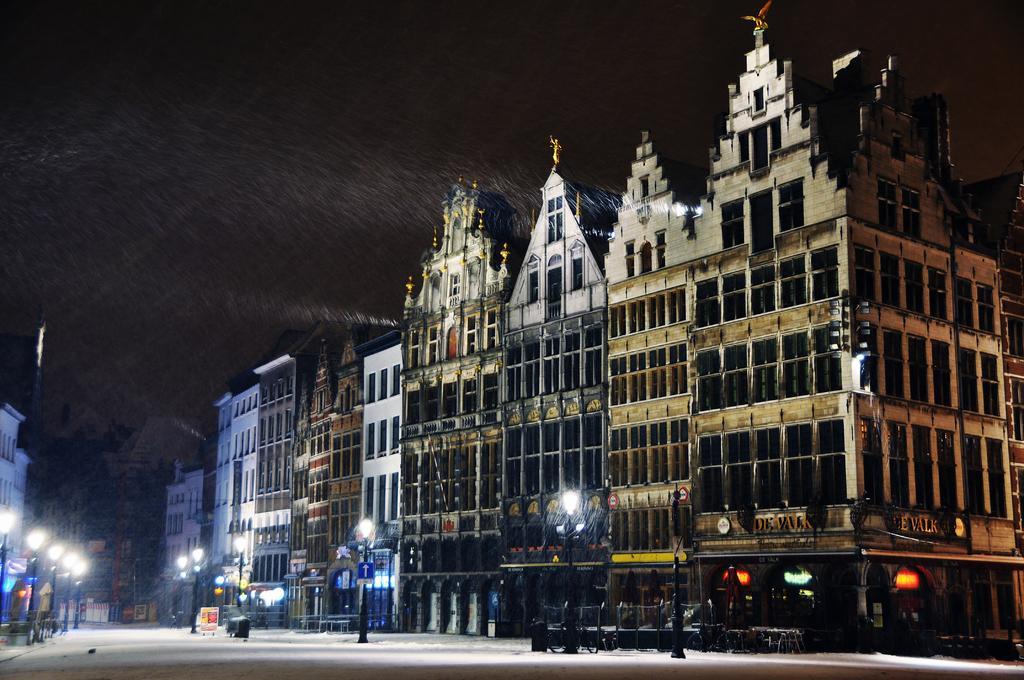How would you summarize this image in a sentence or two? In this image, I can see the buildings with the windows. These are the street lights. This looks like a board and an object. At the top of the image, I can see the sky. I think these are the sculptures, which are at the top of the buildings. 